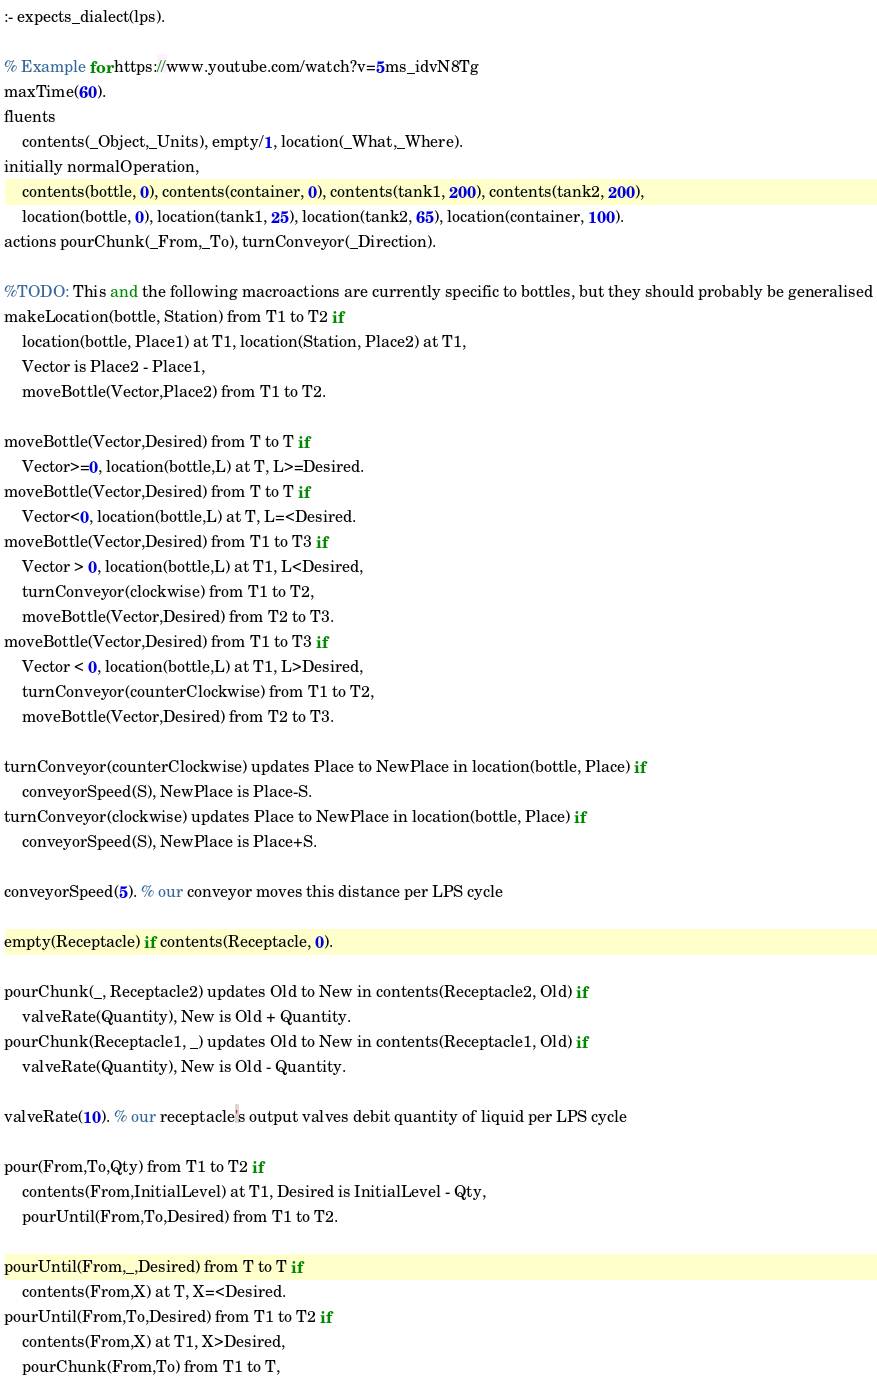<code> <loc_0><loc_0><loc_500><loc_500><_Perl_>:- expects_dialect(lps).

% Example for https://www.youtube.com/watch?v=5ms_idvN8Tg
maxTime(60).
fluents 
	contents(_Object,_Units), empty/1, location(_What,_Where).
initially normalOperation, 
	contents(bottle, 0), contents(container, 0), contents(tank1, 200), contents(tank2, 200),
	location(bottle, 0), location(tank1, 25), location(tank2, 65), location(container, 100).
actions pourChunk(_From,_To), turnConveyor(_Direction).

%TODO: This and the following macroactions are currently specific to bottles, but they should probably be generalised
makeLocation(bottle, Station) from T1 to T2 if 
	location(bottle, Place1) at T1, location(Station, Place2) at T1, 
	Vector is Place2 - Place1, 
	moveBottle(Vector,Place2) from T1 to T2.

moveBottle(Vector,Desired) from T to T if
	Vector>=0, location(bottle,L) at T, L>=Desired.
moveBottle(Vector,Desired) from T to T if
	Vector<0, location(bottle,L) at T, L=<Desired.
moveBottle(Vector,Desired) from T1 to T3 if 
	Vector > 0, location(bottle,L) at T1, L<Desired,
	turnConveyor(clockwise) from T1 to T2,
	moveBottle(Vector,Desired) from T2 to T3.
moveBottle(Vector,Desired) from T1 to T3 if 
	Vector < 0, location(bottle,L) at T1, L>Desired,
	turnConveyor(counterClockwise) from T1 to T2,
	moveBottle(Vector,Desired) from T2 to T3.

turnConveyor(counterClockwise) updates Place to NewPlace in location(bottle, Place) if
	conveyorSpeed(S), NewPlace is Place-S.
turnConveyor(clockwise) updates Place to NewPlace in location(bottle, Place) if
	conveyorSpeed(S), NewPlace is Place+S.

conveyorSpeed(5). % our conveyor moves this distance per LPS cycle

empty(Receptacle) if contents(Receptacle, 0).

pourChunk(_, Receptacle2) updates Old to New in contents(Receptacle2, Old) if 
	valveRate(Quantity), New is Old + Quantity.
pourChunk(Receptacle1, _) updates Old to New in contents(Receptacle1, Old) if 
	valveRate(Quantity), New is Old - Quantity.

valveRate(10). % our receptacle's output valves debit quantity of liquid per LPS cycle

pour(From,To,Qty) from T1 to T2 if
	contents(From,InitialLevel) at T1, Desired is InitialLevel - Qty,
	pourUntil(From,To,Desired) from T1 to T2.

pourUntil(From,_,Desired) from T to T if 
	contents(From,X) at T, X=<Desired.
pourUntil(From,To,Desired) from T1 to T2 if
	contents(From,X) at T1, X>Desired,
	pourChunk(From,To) from T1 to T,</code> 